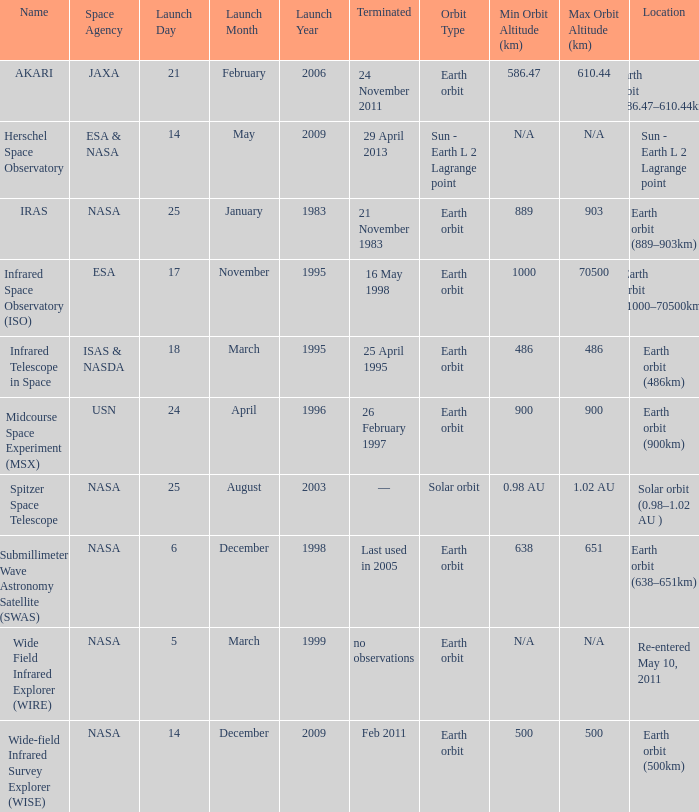When did NASA launch the wide field infrared explorer (wire)? 5 March 1999. 